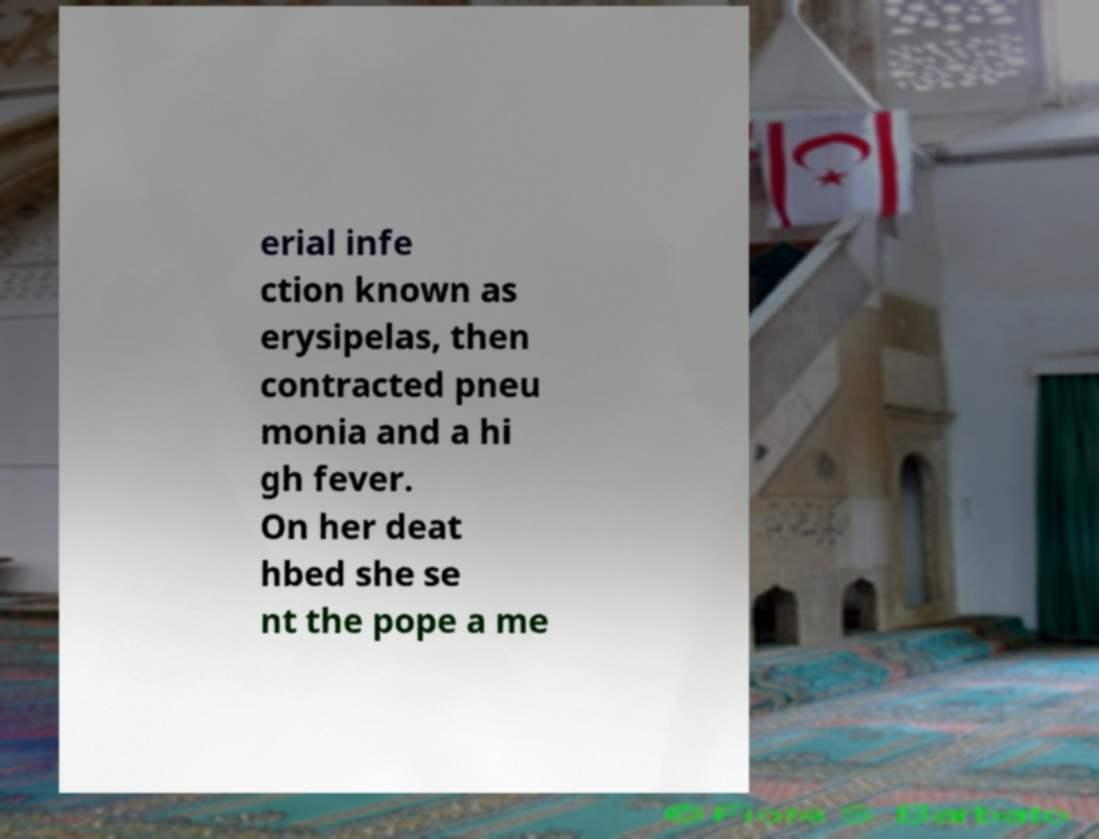Can you read and provide the text displayed in the image?This photo seems to have some interesting text. Can you extract and type it out for me? erial infe ction known as erysipelas, then contracted pneu monia and a hi gh fever. On her deat hbed she se nt the pope a me 